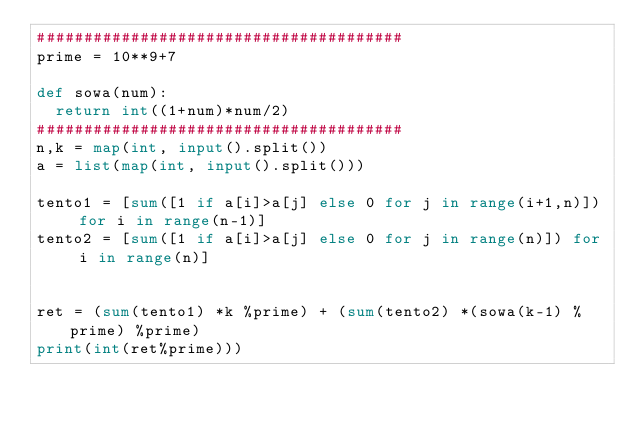Convert code to text. <code><loc_0><loc_0><loc_500><loc_500><_Python_>#######################################
prime = 10**9+7

def sowa(num):
  return int((1+num)*num/2)
#######################################
n,k = map(int, input().split())
a = list(map(int, input().split()))

tento1 = [sum([1 if a[i]>a[j] else 0 for j in range(i+1,n)]) for i in range(n-1)]
tento2 = [sum([1 if a[i]>a[j] else 0 for j in range(n)]) for i in range(n)]


ret = (sum(tento1) *k %prime) + (sum(tento2) *(sowa(k-1) %prime) %prime)
print(int(ret%prime)))
</code> 